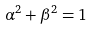<formula> <loc_0><loc_0><loc_500><loc_500>\alpha ^ { 2 } + \beta ^ { 2 } = 1</formula> 